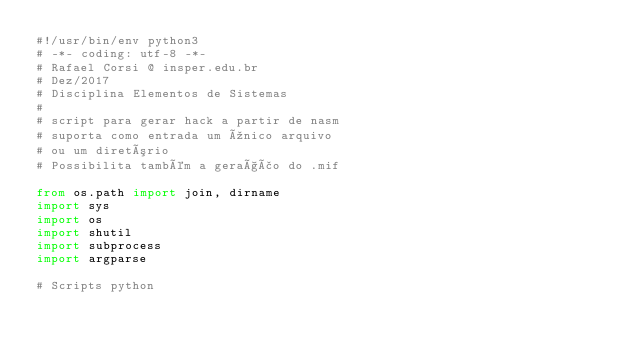Convert code to text. <code><loc_0><loc_0><loc_500><loc_500><_Python_>#!/usr/bin/env python3
# -*- coding: utf-8 -*-
# Rafael Corsi @ insper.edu.br
# Dez/2017
# Disciplina Elementos de Sistemas
#
# script para gerar hack a partir de nasm
# suporta como entrada um único arquivo
# ou um diretório
# Possibilita também a geração do .mif

from os.path import join, dirname
import sys
import os
import shutil
import subprocess
import argparse

# Scripts python</code> 